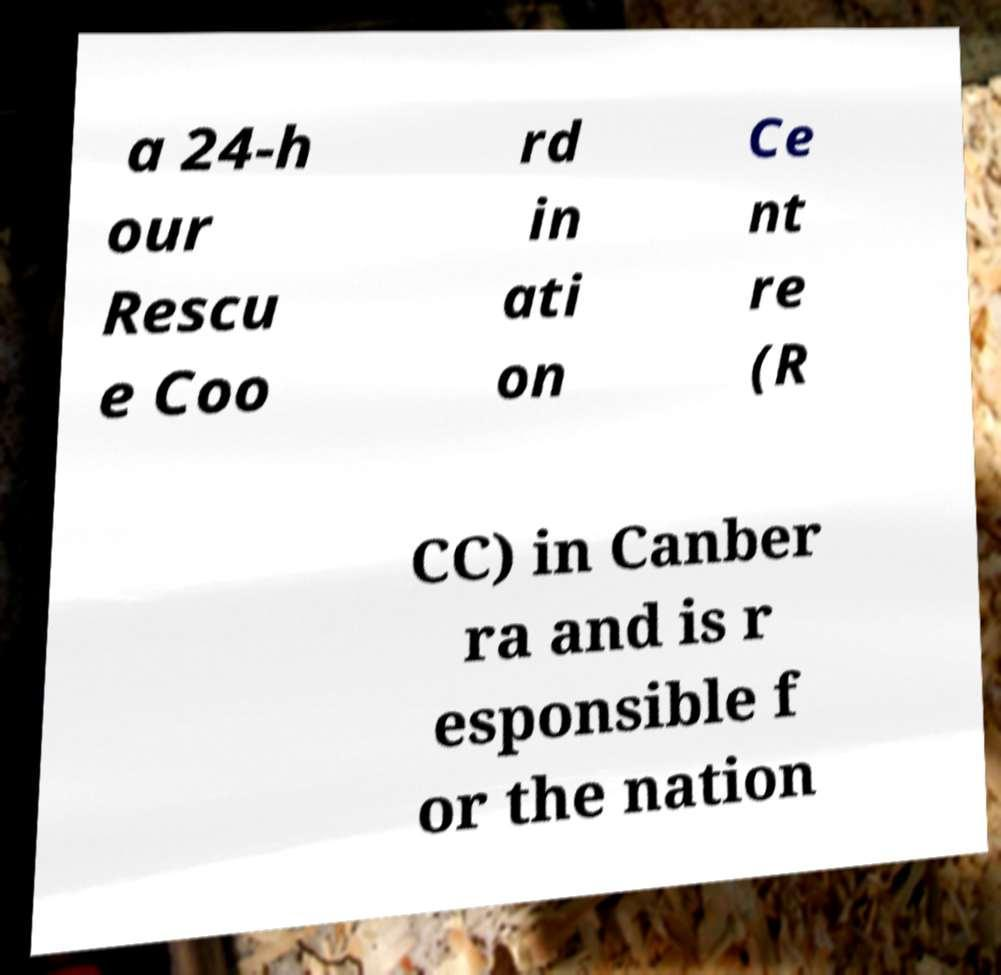I need the written content from this picture converted into text. Can you do that? a 24-h our Rescu e Coo rd in ati on Ce nt re (R CC) in Canber ra and is r esponsible f or the nation 